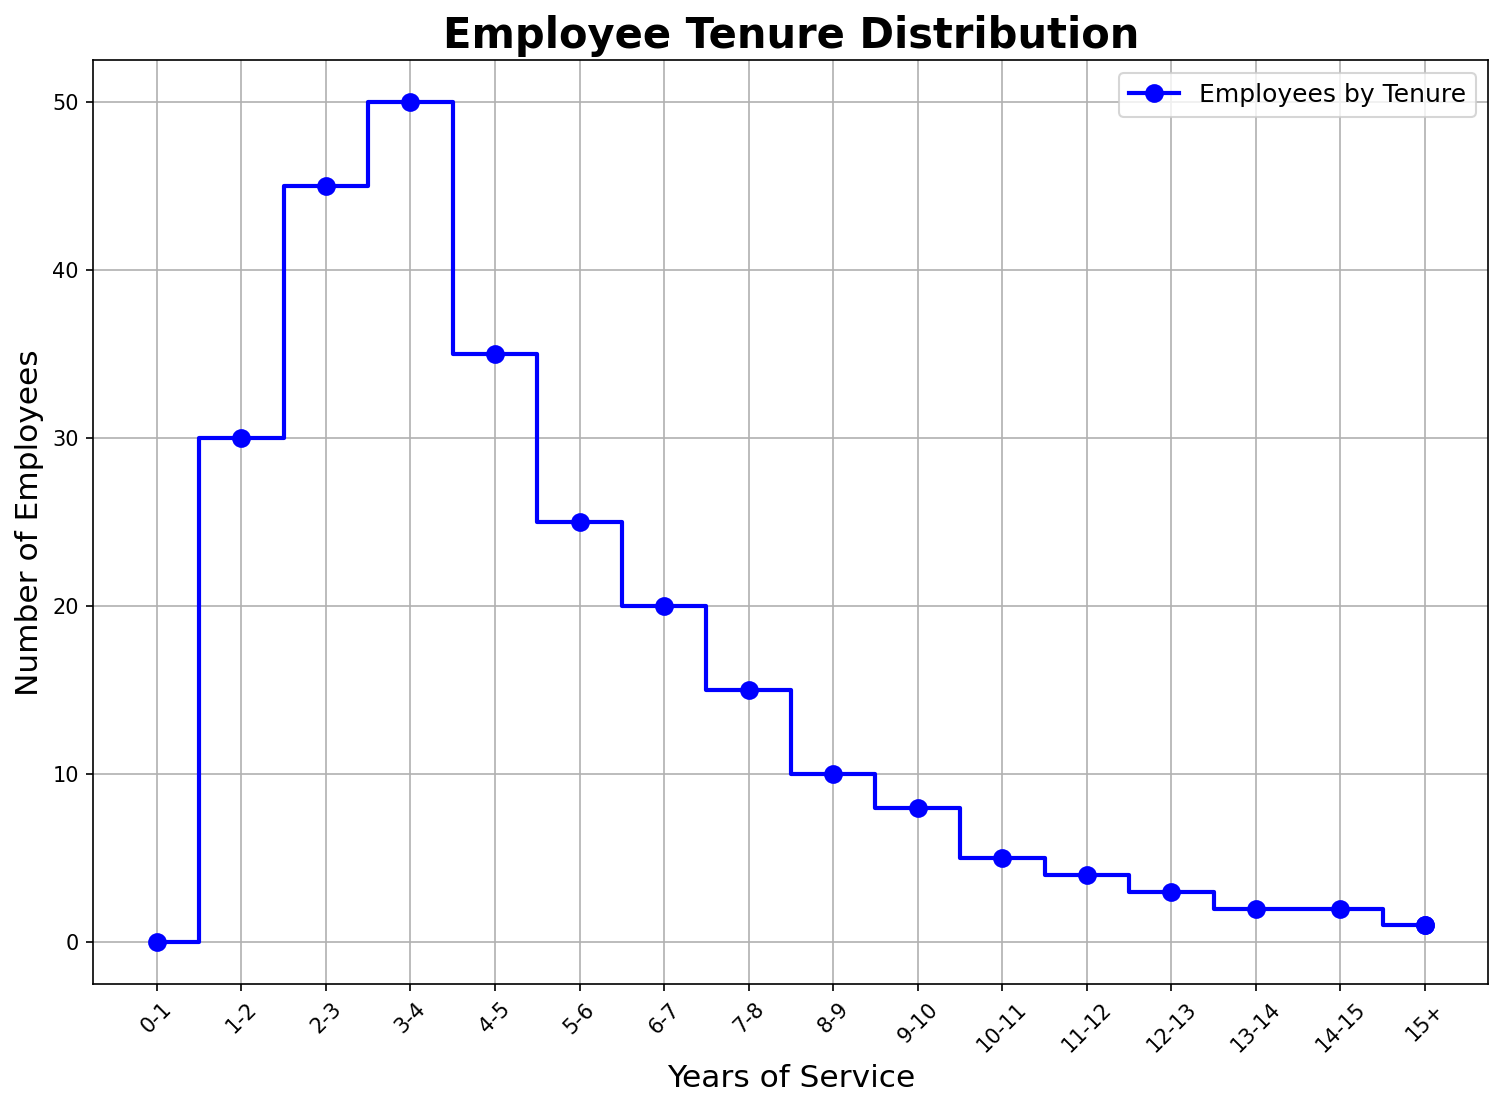What is the total number of employees with 5 to 7 years of service? Sum the number of employees for the respective years. Continuously, 5-6 years have 20 employees, 6-7 years have 15 employees, so 20 + 15 = 35
Answer: 35 How does the number of employees with 0-1 year of service compare to those with over 15 years of service? Check the number of employees in both the categories. 0-1 year has 30 employees, and 15+ years has 1 employee
Answer: 30 is greater than 1 What is the average number of employees in the 0-3 years service range? Add up the number of employees for the years 0-1, 1-2, and 2-3, then divide by the number of years. So, (30 + 45 + 50) / 3 = 125 / 3 ≈ 41.67
Answer: ≈ 41.67 Which year interval has the largest number of employees? Observe the heights of the steps. The highest step corresponds to the 2-3 years interval with 50 employees
Answer: 2-3 years What is the cumulative number of employees with less than 5 years of service? Sum up the number of employees for the years 0-1, 1-2, 2-3, 3-4, and 4-5. So, 30 + 45 + 50 + 35 + 25 = 185
Answer: 185 By how many employees does the 1-2 years interval exceed the 4-5 years interval? Subtract the number of employees in the 4-5 years interval from those in the 1-2 years interval. 45 - 25 = 20
Answer: 20 How many employees are there in the 10+ years service range? Sum up the number of employees in the intervals from 10-11 years to 15+ years. So, 4 + 3 + 2 + 2 + 1 + 1 = 13
Answer: 13 What is the visual attribute that can be used to identify the 10-11 years interval on the plot? The location of the step corresponds to the labeled tick mark on the x-axis at 10-11. The number of employees (height) is indicated by the step reaching up to 4 employees
Answer: Step at x-axis 10-11 and height of 4 employees Is there any interval where the number of employees decreases by more than 30 from the previous interval? Compare the differences in the number of employees between consecutive intervals. The biggest drop is between 2-3 years (50) and 3-4 years (35), which is 50 - 35 = 15
Answer: No 